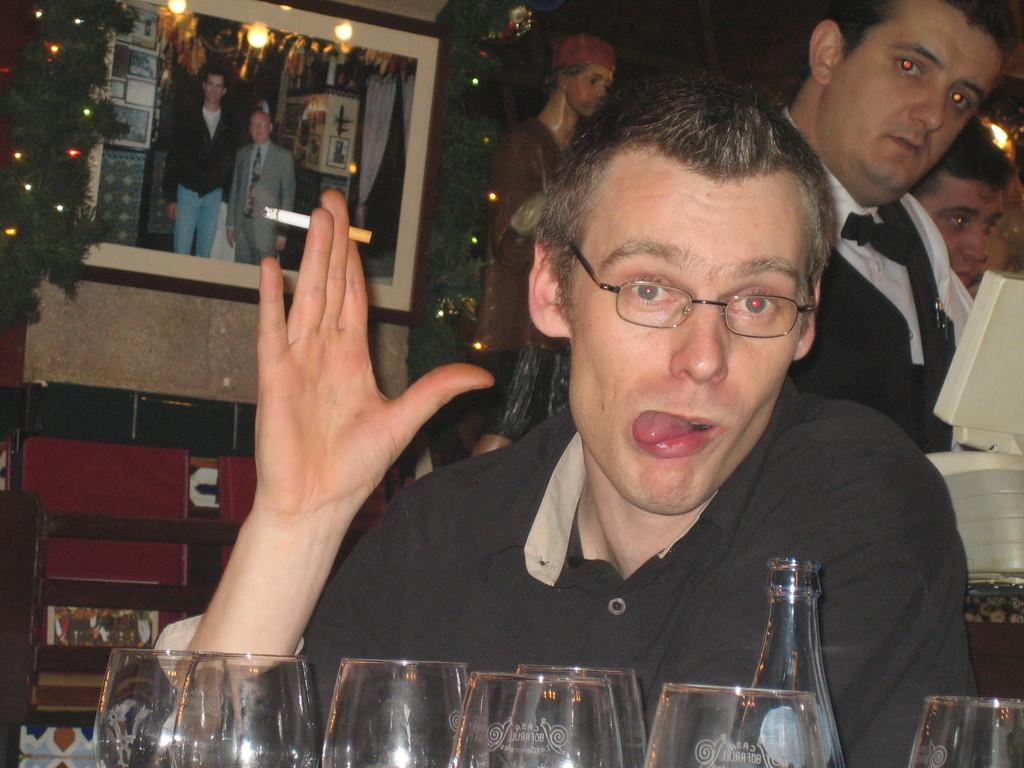What objects are in the image that are used for seeing? There are glasses and a person wearing glasses (specs) in the image. What can be seen in the background of the image? Planets and a frame on the wall are visible in the background of the image. What type of desk is visible in the image? There is no desk present in the image. What request is the person making in the image? There is no indication of a request being made in the image. 